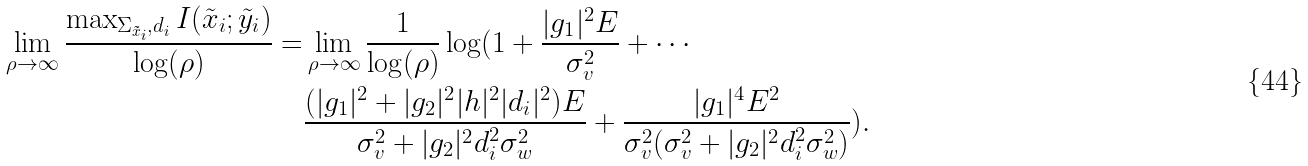Convert formula to latex. <formula><loc_0><loc_0><loc_500><loc_500>\lim _ { \rho \rightarrow \infty } \frac { \max _ { \Sigma _ { \tilde { x } _ { i } } , d _ { i } } I ( \tilde { x } _ { i } ; \tilde { y } _ { i } ) } { \log ( \rho ) } = & \lim _ { \rho \rightarrow \infty } \frac { 1 } { \log ( \rho ) } \log ( 1 + \frac { | g _ { 1 } | ^ { 2 } E } { \sigma _ { v } ^ { 2 } } + \cdots \\ & \frac { ( | g _ { 1 } | ^ { 2 } + | g _ { 2 } | ^ { 2 } | h | ^ { 2 } | d _ { i } | ^ { 2 } ) E } { \sigma _ { v } ^ { 2 } + | g _ { 2 } | ^ { 2 } d _ { i } ^ { 2 } \sigma _ { w } ^ { 2 } } + \frac { | g _ { 1 } | ^ { 4 } E ^ { 2 } } { \sigma _ { v } ^ { 2 } ( \sigma _ { v } ^ { 2 } + | g _ { 2 } | ^ { 2 } d _ { i } ^ { 2 } \sigma _ { w } ^ { 2 } ) } ) .</formula> 